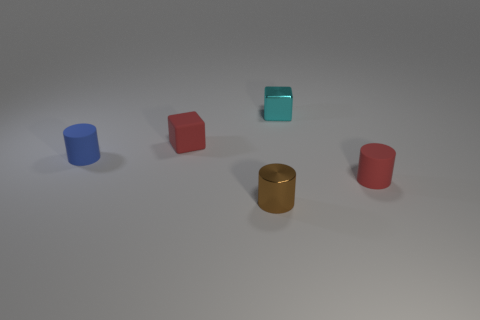There is a small red thing left of the small metal object behind the tiny brown cylinder; is there a small brown cylinder that is on the left side of it?
Offer a terse response. No. There is a small red object that is the same shape as the blue thing; what is it made of?
Provide a succinct answer. Rubber. How many red matte objects are left of the cyan cube right of the blue matte object?
Ensure brevity in your answer.  1. How big is the rubber cylinder that is right of the thing that is in front of the small cylinder to the right of the small brown thing?
Keep it short and to the point. Small. The rubber cylinder in front of the small rubber cylinder that is on the left side of the tiny brown shiny cylinder is what color?
Your response must be concise. Red. How many other objects are the same material as the small red cylinder?
Your response must be concise. 2. How many other things are the same color as the tiny rubber block?
Make the answer very short. 1. What material is the red object that is to the right of the red matte thing that is to the left of the red rubber cylinder made of?
Your answer should be very brief. Rubber. Are any rubber objects visible?
Make the answer very short. Yes. What size is the red object that is behind the tiny rubber thing right of the tiny brown cylinder?
Make the answer very short. Small. 